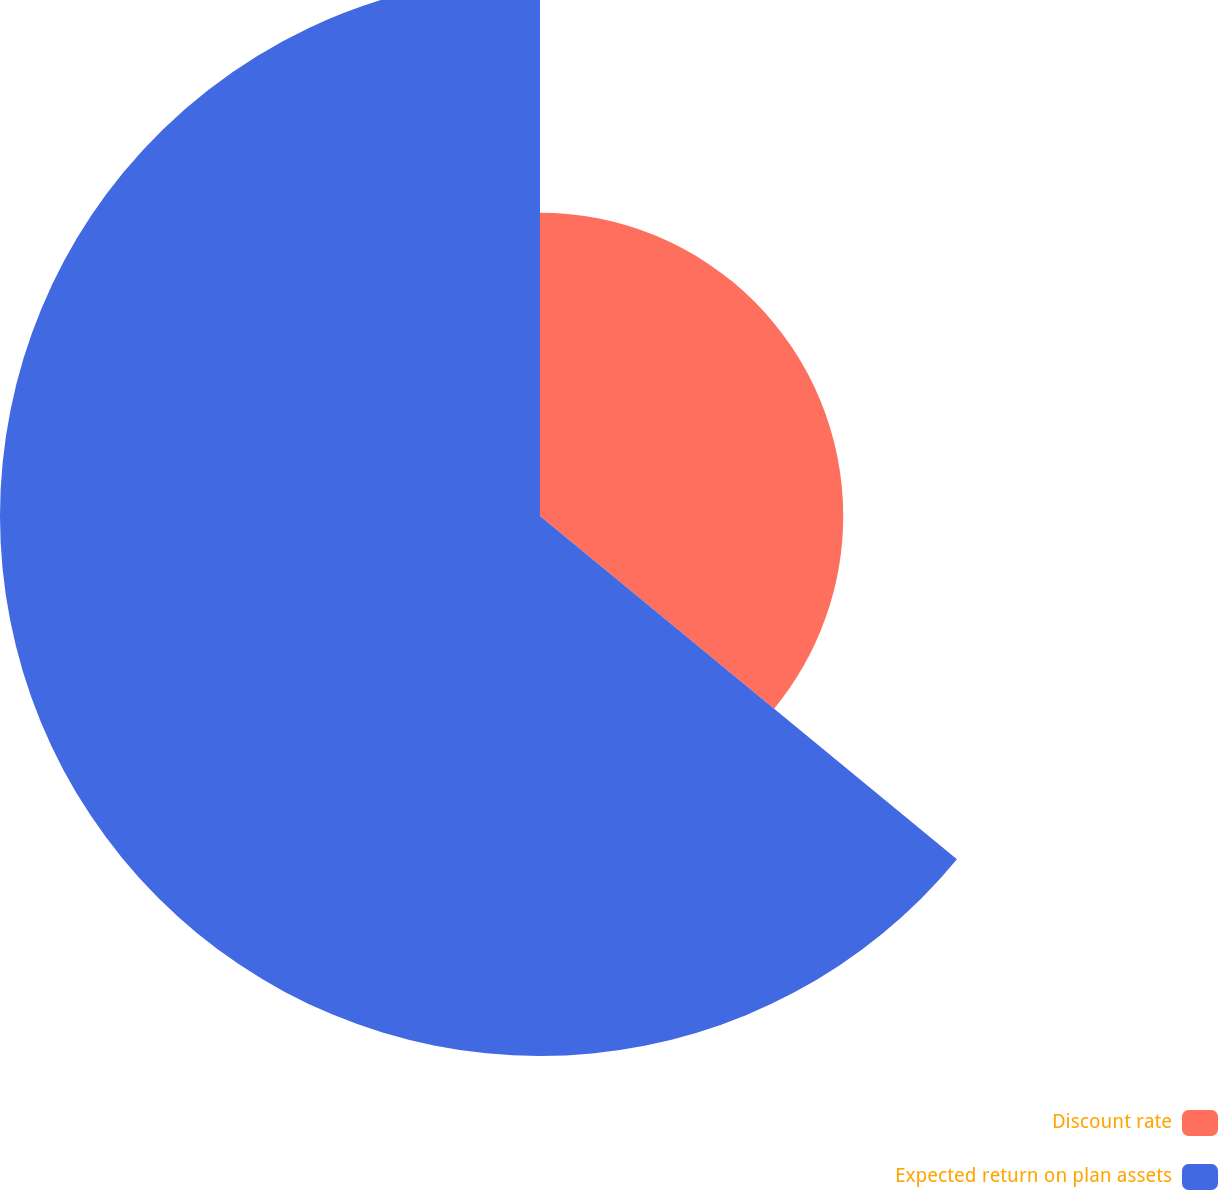Convert chart. <chart><loc_0><loc_0><loc_500><loc_500><pie_chart><fcel>Discount rate<fcel>Expected return on plan assets<nl><fcel>35.96%<fcel>64.04%<nl></chart> 